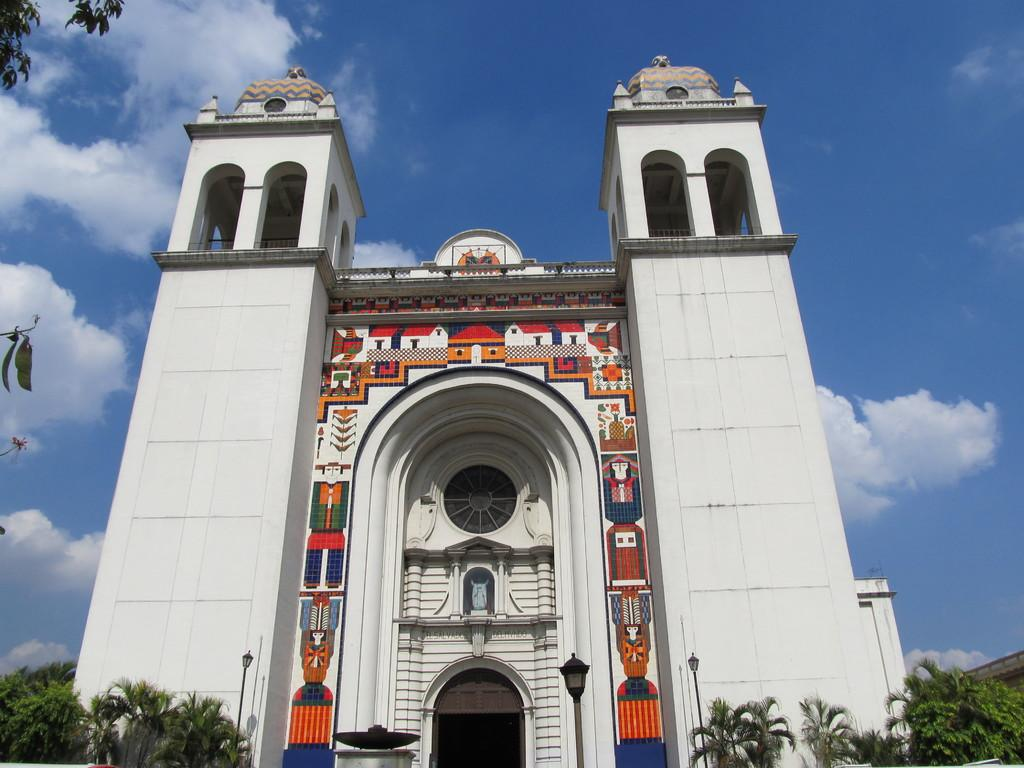What type of structure is present in the image? There is a building in the image. What architectural feature can be seen on the building? The building has an arch. What type of lighting is present in the image? There are street lights in the image. What type of vegetation is visible in the image? Trees are visible from left to right in the image. How would you describe the sky in the image? The sky is blue and cloudy in the image. What type of joke is being told by the scale in the image? There is no scale or joke present in the image. What is the source of hate in the image? There is no hate or indication of any negative emotions in the image. 